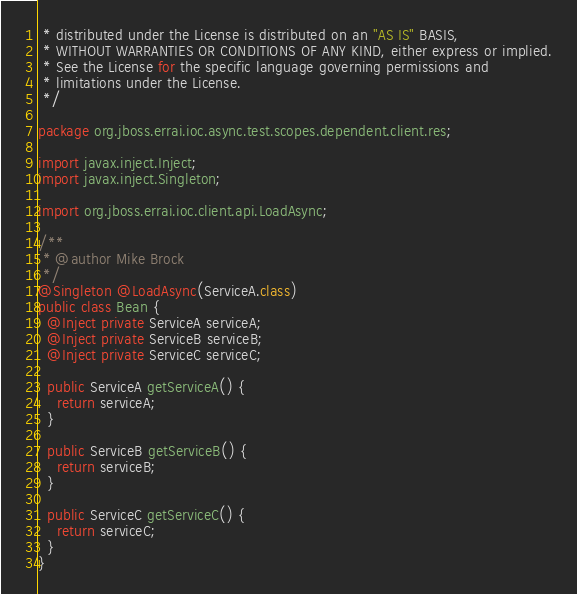Convert code to text. <code><loc_0><loc_0><loc_500><loc_500><_Java_> * distributed under the License is distributed on an "AS IS" BASIS,
 * WITHOUT WARRANTIES OR CONDITIONS OF ANY KIND, either express or implied.
 * See the License for the specific language governing permissions and
 * limitations under the License.
 */

package org.jboss.errai.ioc.async.test.scopes.dependent.client.res;

import javax.inject.Inject;
import javax.inject.Singleton;

import org.jboss.errai.ioc.client.api.LoadAsync;

/**
 * @author Mike Brock
 */
@Singleton @LoadAsync(ServiceA.class)
public class Bean {
  @Inject private ServiceA serviceA;
  @Inject private ServiceB serviceB;
  @Inject private ServiceC serviceC;

  public ServiceA getServiceA() {
    return serviceA;
  }

  public ServiceB getServiceB() {
    return serviceB;
  }

  public ServiceC getServiceC() {
    return serviceC;
  }
}
</code> 